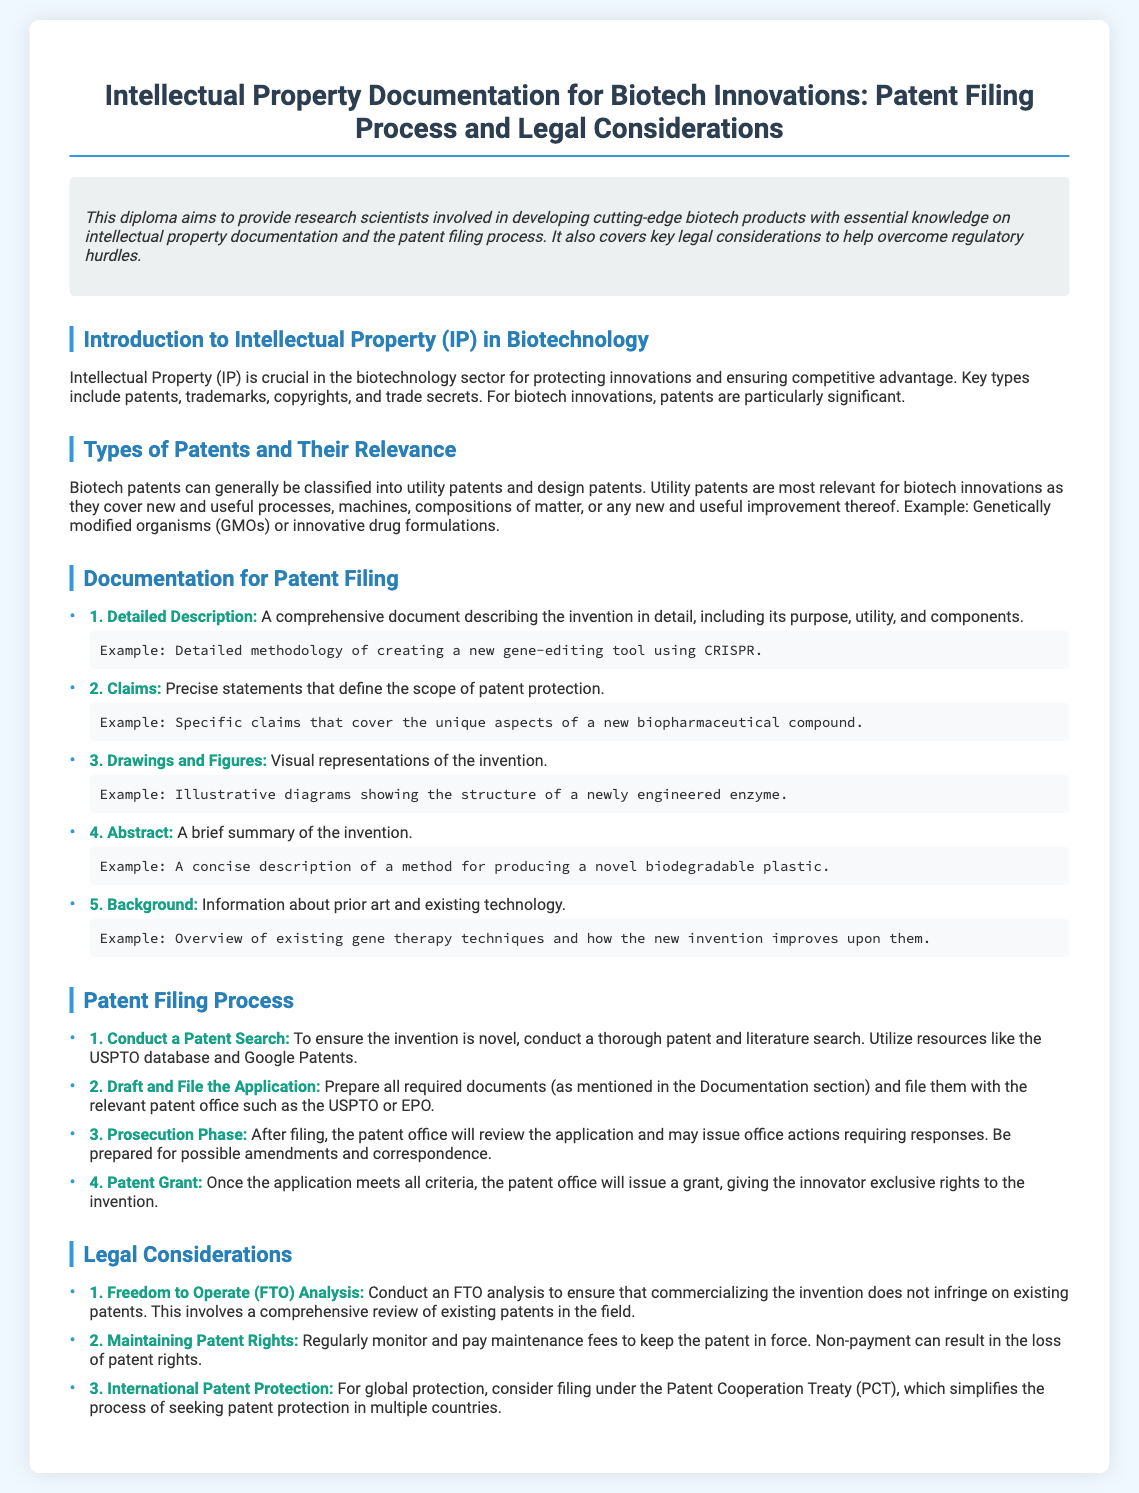What is the title of the diploma? The title of the diploma is specified at the top of the document.
Answer: Intellectual Property Documentation for Biotech Innovations: Patent Filing Process and Legal Considerations What is the main subject of the diploma? The main subject is summarized in the overview section, highlighting key areas covered.
Answer: Intellectual property documentation and patent filing process What are the two types of patents mentioned? The types of patents are outlined in the section discussing their relevance.
Answer: Utility patents and design patents What does FTO stand for in the legal considerations? The acronym is defined in the legal considerations section of the document.
Answer: Freedom to Operate What is the first step in the patent filing process? This is listed in the step-by-step guidance for the patent filing procedure.
Answer: Conduct a Patent Search What is one example of the required documentation for patent filing? The document lists various types of documentation needed for patent filing.
Answer: Detailed Description What is the purpose of the abstract in patent documentation? The role of the abstract is outlined in the documentation section.
Answer: A brief summary of the invention Which process simplifies obtaining patents in multiple countries? This process is mentioned in the legal considerations section.
Answer: Patent Cooperation Treaty (PCT) 